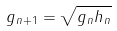<formula> <loc_0><loc_0><loc_500><loc_500>g _ { n + 1 } = \sqrt { g _ { n } h _ { n } }</formula> 